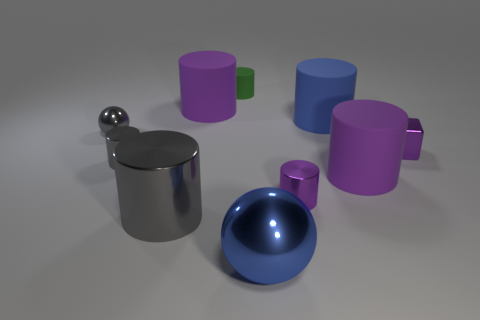Which objects in this image look like they could hold liquid? From the given image, there are two objects that seem capable of holding liquid. One is a metallic cylindrical container with a handle, which resembles a mug, and the other is a blue bowl-shaped object on the lower right. Both have concave shapes suitable for containing fluids. 